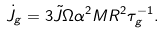<formula> <loc_0><loc_0><loc_500><loc_500>\dot { J } _ { g } = 3 \tilde { J } \Omega \alpha ^ { 2 } M R ^ { 2 } \tau _ { g } ^ { - 1 } .</formula> 